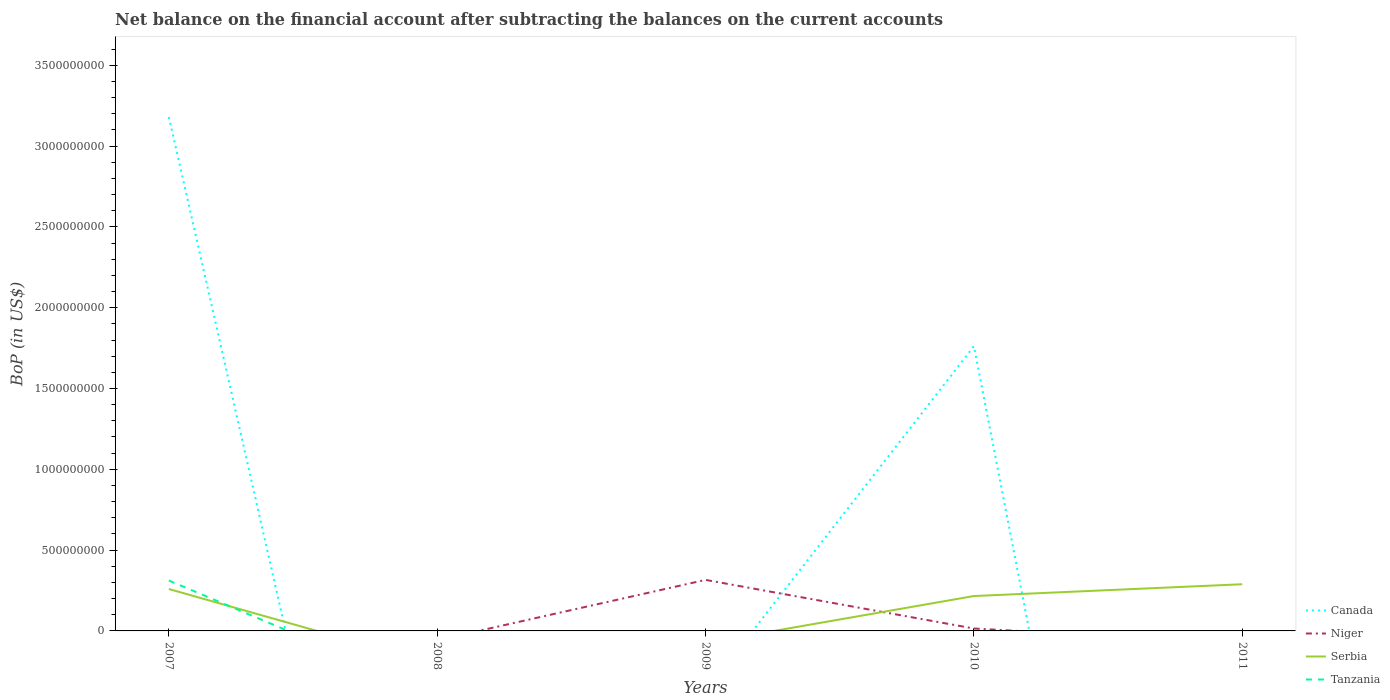How many different coloured lines are there?
Offer a very short reply. 4. Does the line corresponding to Serbia intersect with the line corresponding to Canada?
Offer a terse response. Yes. What is the total Balance of Payments in Serbia in the graph?
Provide a succinct answer. -2.96e+07. What is the difference between the highest and the second highest Balance of Payments in Serbia?
Provide a short and direct response. 2.89e+08. What is the difference between the highest and the lowest Balance of Payments in Canada?
Keep it short and to the point. 2. How many lines are there?
Offer a terse response. 4. What is the difference between two consecutive major ticks on the Y-axis?
Your answer should be very brief. 5.00e+08. How many legend labels are there?
Your answer should be very brief. 4. What is the title of the graph?
Keep it short and to the point. Net balance on the financial account after subtracting the balances on the current accounts. Does "China" appear as one of the legend labels in the graph?
Offer a very short reply. No. What is the label or title of the X-axis?
Make the answer very short. Years. What is the label or title of the Y-axis?
Provide a succinct answer. BoP (in US$). What is the BoP (in US$) in Canada in 2007?
Keep it short and to the point. 3.18e+09. What is the BoP (in US$) in Niger in 2007?
Your answer should be compact. 0. What is the BoP (in US$) in Serbia in 2007?
Your answer should be compact. 2.59e+08. What is the BoP (in US$) of Tanzania in 2007?
Give a very brief answer. 3.12e+08. What is the BoP (in US$) in Canada in 2008?
Make the answer very short. 0. What is the BoP (in US$) in Niger in 2008?
Offer a very short reply. 0. What is the BoP (in US$) of Serbia in 2008?
Your answer should be compact. 0. What is the BoP (in US$) in Tanzania in 2008?
Give a very brief answer. 0. What is the BoP (in US$) of Niger in 2009?
Provide a succinct answer. 3.16e+08. What is the BoP (in US$) in Serbia in 2009?
Your response must be concise. 0. What is the BoP (in US$) in Canada in 2010?
Your answer should be compact. 1.76e+09. What is the BoP (in US$) of Niger in 2010?
Give a very brief answer. 1.49e+07. What is the BoP (in US$) in Serbia in 2010?
Give a very brief answer. 2.16e+08. What is the BoP (in US$) in Tanzania in 2010?
Provide a succinct answer. 0. What is the BoP (in US$) of Canada in 2011?
Make the answer very short. 0. What is the BoP (in US$) in Niger in 2011?
Ensure brevity in your answer.  0. What is the BoP (in US$) of Serbia in 2011?
Make the answer very short. 2.89e+08. Across all years, what is the maximum BoP (in US$) in Canada?
Provide a short and direct response. 3.18e+09. Across all years, what is the maximum BoP (in US$) of Niger?
Your answer should be compact. 3.16e+08. Across all years, what is the maximum BoP (in US$) in Serbia?
Your answer should be very brief. 2.89e+08. Across all years, what is the maximum BoP (in US$) of Tanzania?
Keep it short and to the point. 3.12e+08. Across all years, what is the minimum BoP (in US$) of Canada?
Keep it short and to the point. 0. Across all years, what is the minimum BoP (in US$) in Niger?
Your answer should be very brief. 0. What is the total BoP (in US$) of Canada in the graph?
Keep it short and to the point. 4.94e+09. What is the total BoP (in US$) of Niger in the graph?
Offer a terse response. 3.31e+08. What is the total BoP (in US$) of Serbia in the graph?
Your answer should be compact. 7.64e+08. What is the total BoP (in US$) in Tanzania in the graph?
Provide a succinct answer. 3.12e+08. What is the difference between the BoP (in US$) of Canada in 2007 and that in 2010?
Your answer should be compact. 1.42e+09. What is the difference between the BoP (in US$) of Serbia in 2007 and that in 2010?
Your response must be concise. 4.34e+07. What is the difference between the BoP (in US$) in Serbia in 2007 and that in 2011?
Offer a terse response. -2.96e+07. What is the difference between the BoP (in US$) of Niger in 2009 and that in 2010?
Ensure brevity in your answer.  3.01e+08. What is the difference between the BoP (in US$) in Serbia in 2010 and that in 2011?
Ensure brevity in your answer.  -7.30e+07. What is the difference between the BoP (in US$) in Canada in 2007 and the BoP (in US$) in Niger in 2009?
Keep it short and to the point. 2.86e+09. What is the difference between the BoP (in US$) of Canada in 2007 and the BoP (in US$) of Niger in 2010?
Make the answer very short. 3.17e+09. What is the difference between the BoP (in US$) of Canada in 2007 and the BoP (in US$) of Serbia in 2010?
Provide a short and direct response. 2.96e+09. What is the difference between the BoP (in US$) of Canada in 2007 and the BoP (in US$) of Serbia in 2011?
Keep it short and to the point. 2.89e+09. What is the difference between the BoP (in US$) in Niger in 2009 and the BoP (in US$) in Serbia in 2010?
Offer a very short reply. 9.98e+07. What is the difference between the BoP (in US$) of Niger in 2009 and the BoP (in US$) of Serbia in 2011?
Offer a very short reply. 2.68e+07. What is the difference between the BoP (in US$) of Canada in 2010 and the BoP (in US$) of Serbia in 2011?
Ensure brevity in your answer.  1.47e+09. What is the difference between the BoP (in US$) in Niger in 2010 and the BoP (in US$) in Serbia in 2011?
Keep it short and to the point. -2.74e+08. What is the average BoP (in US$) in Canada per year?
Provide a short and direct response. 9.88e+08. What is the average BoP (in US$) of Niger per year?
Provide a short and direct response. 6.61e+07. What is the average BoP (in US$) in Serbia per year?
Offer a terse response. 1.53e+08. What is the average BoP (in US$) in Tanzania per year?
Your answer should be compact. 6.24e+07. In the year 2007, what is the difference between the BoP (in US$) of Canada and BoP (in US$) of Serbia?
Provide a short and direct response. 2.92e+09. In the year 2007, what is the difference between the BoP (in US$) of Canada and BoP (in US$) of Tanzania?
Offer a terse response. 2.87e+09. In the year 2007, what is the difference between the BoP (in US$) of Serbia and BoP (in US$) of Tanzania?
Provide a short and direct response. -5.25e+07. In the year 2010, what is the difference between the BoP (in US$) in Canada and BoP (in US$) in Niger?
Offer a terse response. 1.75e+09. In the year 2010, what is the difference between the BoP (in US$) of Canada and BoP (in US$) of Serbia?
Give a very brief answer. 1.55e+09. In the year 2010, what is the difference between the BoP (in US$) in Niger and BoP (in US$) in Serbia?
Your answer should be compact. -2.01e+08. What is the ratio of the BoP (in US$) of Canada in 2007 to that in 2010?
Ensure brevity in your answer.  1.81. What is the ratio of the BoP (in US$) in Serbia in 2007 to that in 2010?
Ensure brevity in your answer.  1.2. What is the ratio of the BoP (in US$) of Serbia in 2007 to that in 2011?
Keep it short and to the point. 0.9. What is the ratio of the BoP (in US$) of Niger in 2009 to that in 2010?
Your response must be concise. 21.2. What is the ratio of the BoP (in US$) of Serbia in 2010 to that in 2011?
Offer a terse response. 0.75. What is the difference between the highest and the second highest BoP (in US$) in Serbia?
Offer a terse response. 2.96e+07. What is the difference between the highest and the lowest BoP (in US$) in Canada?
Give a very brief answer. 3.18e+09. What is the difference between the highest and the lowest BoP (in US$) in Niger?
Your response must be concise. 3.16e+08. What is the difference between the highest and the lowest BoP (in US$) in Serbia?
Make the answer very short. 2.89e+08. What is the difference between the highest and the lowest BoP (in US$) in Tanzania?
Your answer should be compact. 3.12e+08. 